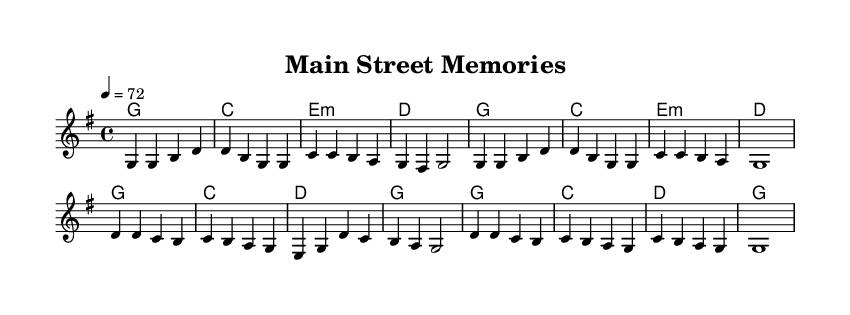What is the key signature of this music? The key signature displayed at the beginning of the score indicates the presence of one sharp. Specifically, it shows that the music is in G major.
Answer: G major What is the time signature of this music? The time signature, indicated by the notation at the start, is 4/4, which means there are four beats in each measure with a quarter note receiving one beat.
Answer: 4/4 What is the tempo marking for this piece? The tempo marking at the beginning states "4 = 72", indicating that there are 72 beats per minute, and the quarter note gets one beat.
Answer: 72 How many measures are in the verse? Counting the measures in the verse section of the sheet music shows a total of 8 measures before the chorus begins.
Answer: 8 What is the first lyric of the song? The first lyric displayed in the verse section is "Old brick fa -- cades and fa -- ded signs," which indicates the opening theme of the piece.
Answer: Old brick fa -- cades How does the chorus rhythmically compare to the verse? In analyzing the chorus compared to the verse, the chorus contains a repeated rhythmic pattern, which is consistent with the overall meter but emphasizes the lyrical content.
Answer: Repeated pattern What is the main theme of the lyrics? The lyrics convey nostalgia for a changing environment while cherishing enduring memories, which reflects a broader emotional sentiment often found in contemporary country ballads.
Answer: Nostalgia and change 